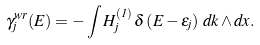Convert formula to latex. <formula><loc_0><loc_0><loc_500><loc_500>\gamma _ { j } ^ { w r } ( E ) = - \int H ^ { ( 1 ) } _ { j } \, \delta \left ( E - \varepsilon _ { j } \right ) \, d k \wedge d x .</formula> 